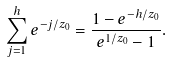<formula> <loc_0><loc_0><loc_500><loc_500>\sum _ { j = 1 } ^ { h } e ^ { - j / z _ { 0 } } = \frac { 1 - e ^ { - h / z _ { 0 } } } { e ^ { 1 / z _ { 0 } } - 1 } .</formula> 